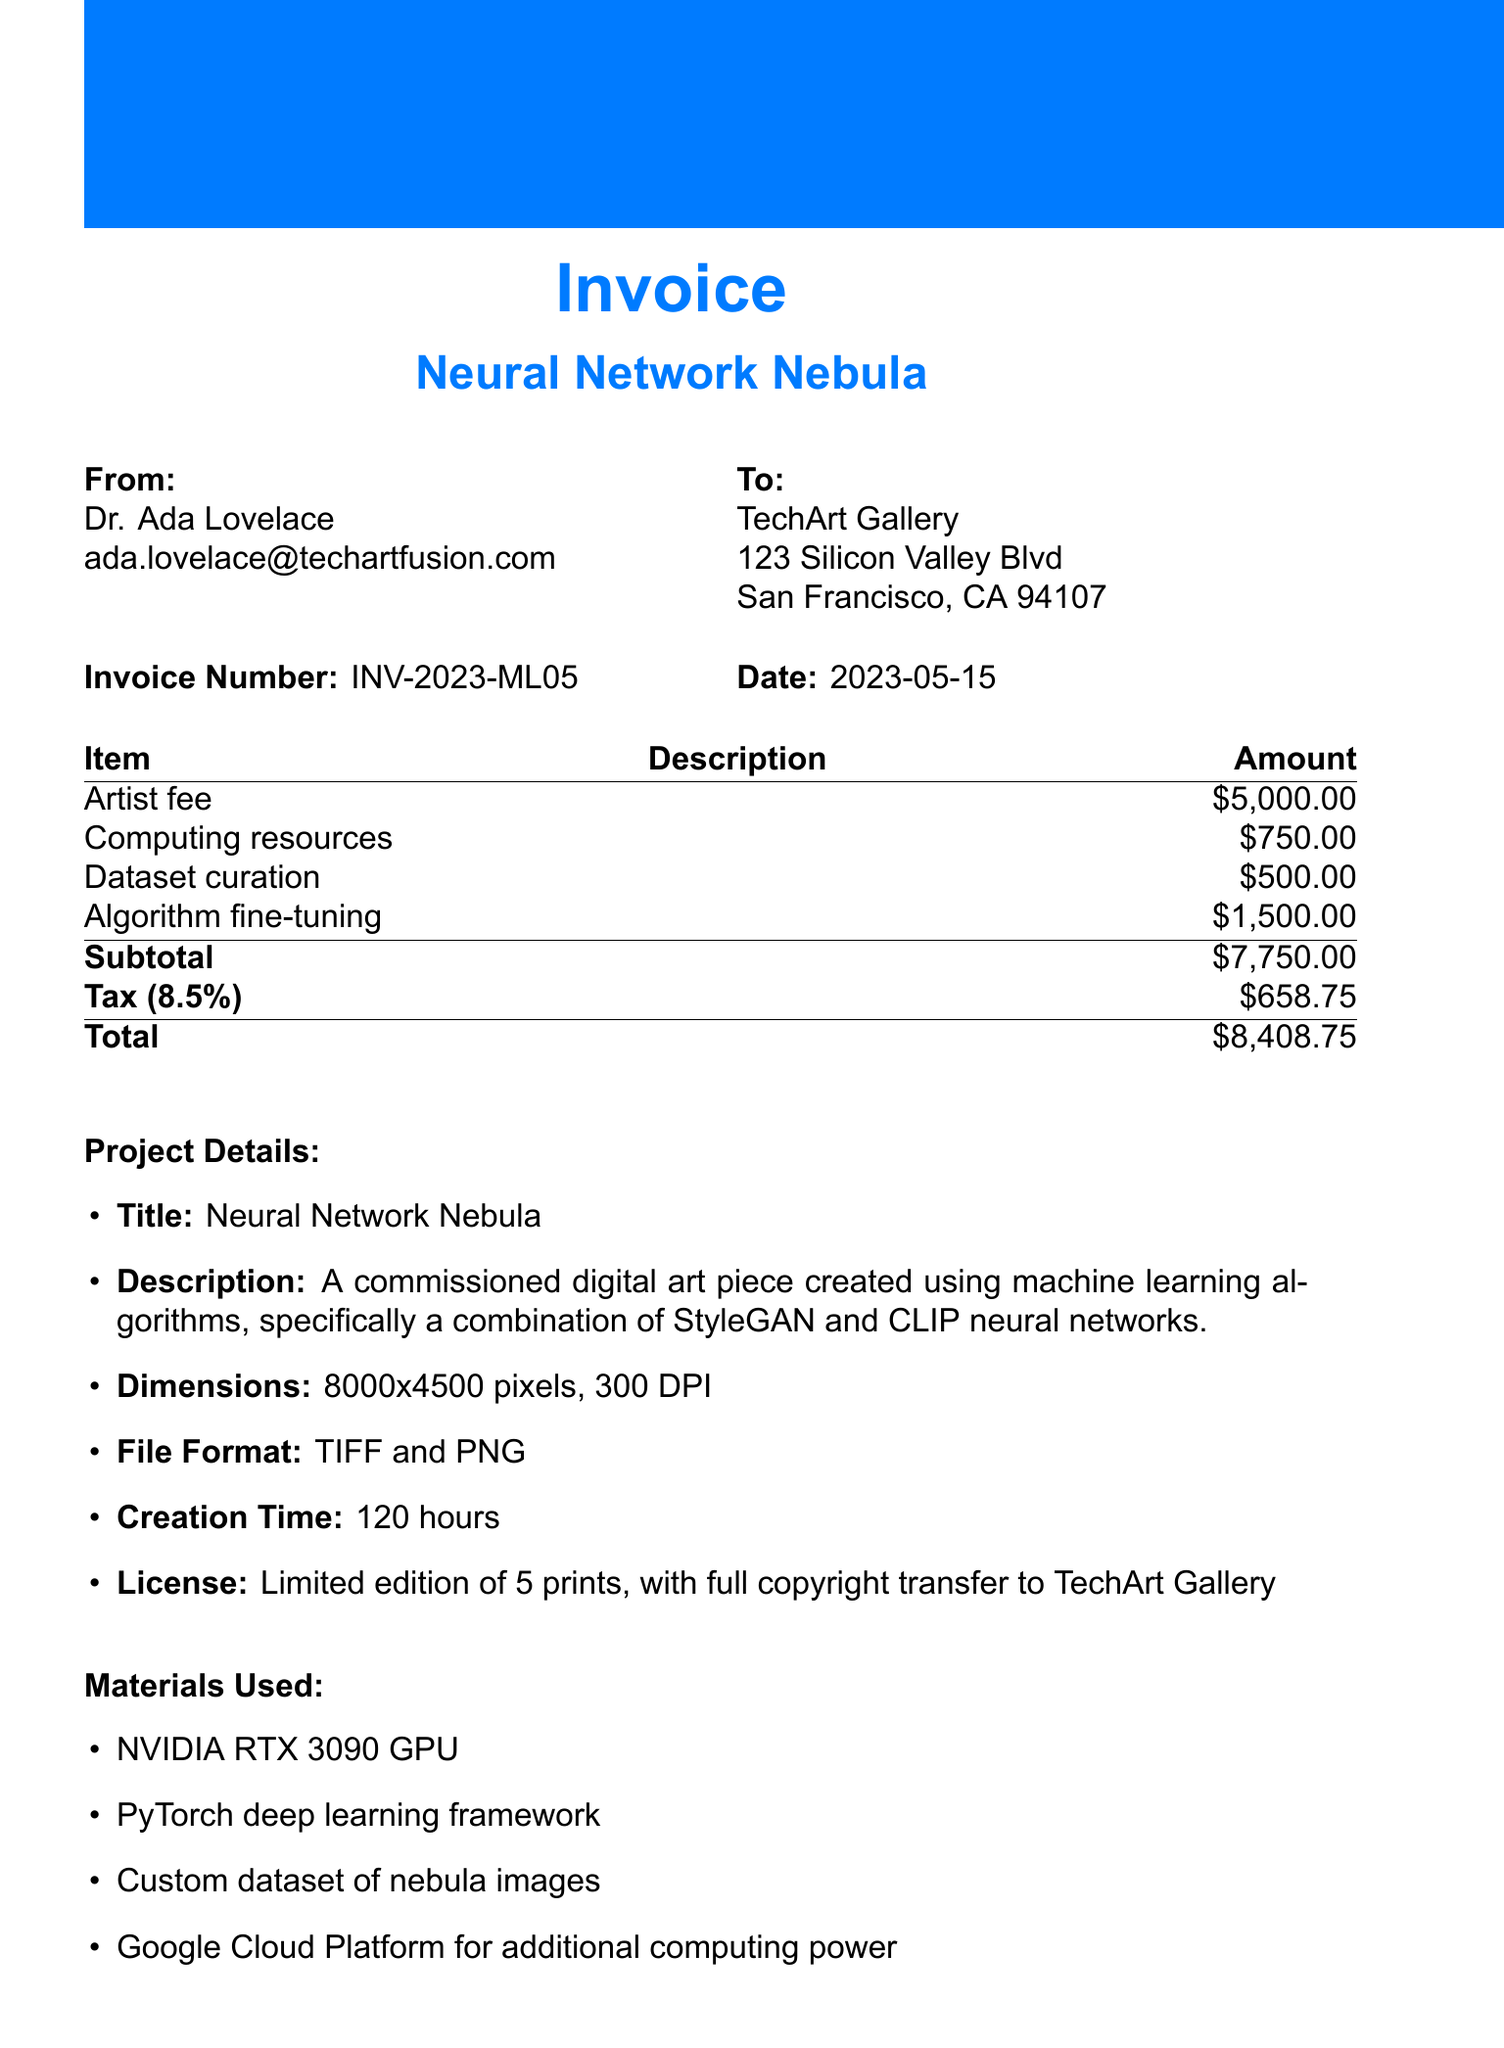What is the receipt number? The receipt number is a unique identifier for this invoice.
Answer: INV-2023-ML05 Who is the artist? The artist's name is provided in the document.
Answer: Dr. Ada Lovelace What is the total amount due? The total amount due is the complete financial charge that includes taxes.
Answer: $8408.75 What is the creation time of the art piece? The creation time indicates how long the artist took to complete the artwork.
Answer: 120 hours What are the payment terms? The payment terms specify when the payment is expected to be made.
Answer: Due within 30 days of receipt What materials were used in the project? Several specific materials are listed in the document related to the creation of the artwork.
Answer: NVIDIA RTX 3090 GPU, PyTorch deep learning framework, Custom dataset of nebula images, Google Cloud Platform for additional computing power How many prints are being produced? The license section mentions the number of limited edition prints available.
Answer: 5 prints Which neural networks were used in the project? The project description details which machine learning techniques were utilized.
Answer: StyleGAN and CLIP neural networks What is the file format of the finished artwork? The file format section specifies the types of files in which the artwork is saved.
Answer: TIFF and PNG 